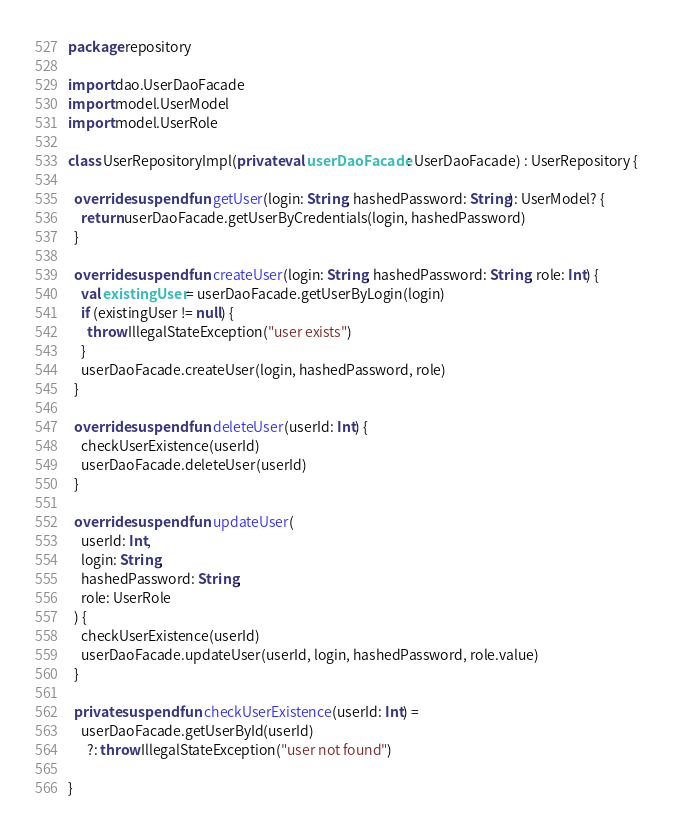Convert code to text. <code><loc_0><loc_0><loc_500><loc_500><_Kotlin_>package repository

import dao.UserDaoFacade
import model.UserModel
import model.UserRole

class UserRepositoryImpl(private val userDaoFacade: UserDaoFacade) : UserRepository {

  override suspend fun getUser(login: String, hashedPassword: String): UserModel? {
    return userDaoFacade.getUserByCredentials(login, hashedPassword)
  }

  override suspend fun createUser(login: String, hashedPassword: String, role: Int) {
    val existingUser = userDaoFacade.getUserByLogin(login)
    if (existingUser != null) {
      throw IllegalStateException("user exists")
    }
    userDaoFacade.createUser(login, hashedPassword, role)
  }

  override suspend fun deleteUser(userId: Int) {
    checkUserExistence(userId)
    userDaoFacade.deleteUser(userId)
  }

  override suspend fun updateUser(
    userId: Int,
    login: String,
    hashedPassword: String,
    role: UserRole
  ) {
    checkUserExistence(userId)
    userDaoFacade.updateUser(userId, login, hashedPassword, role.value)
  }

  private suspend fun checkUserExistence(userId: Int) =
    userDaoFacade.getUserById(userId)
      ?: throw IllegalStateException("user not found")

}</code> 